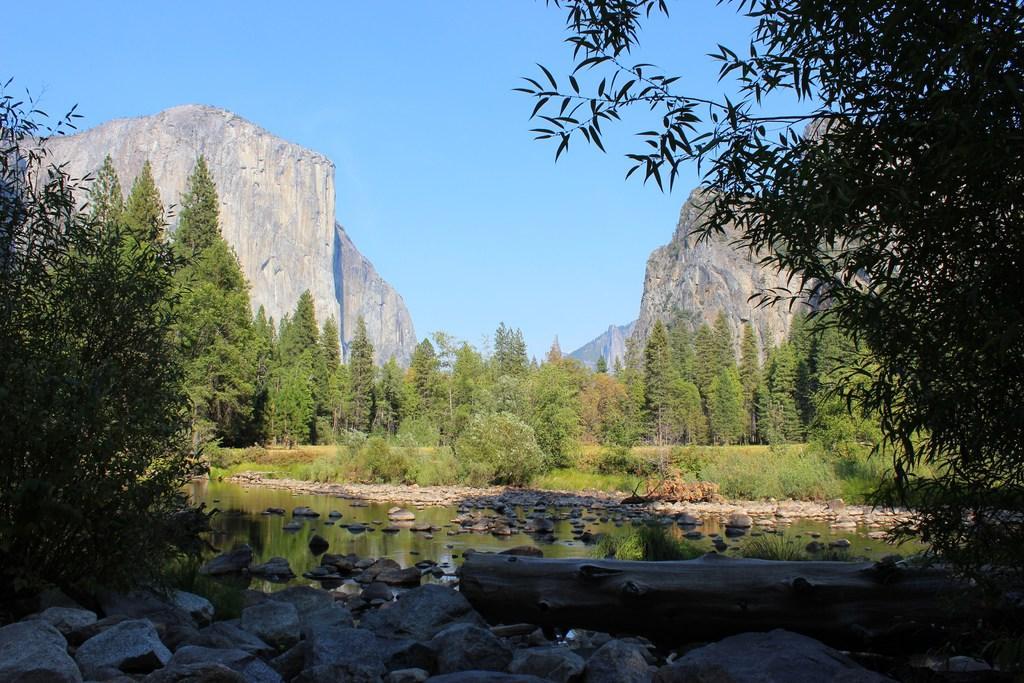Could you give a brief overview of what you see in this image? In this image, we can see so many trees, plants, rocks, wooden log and water. Background we can see rock hills and sky. 